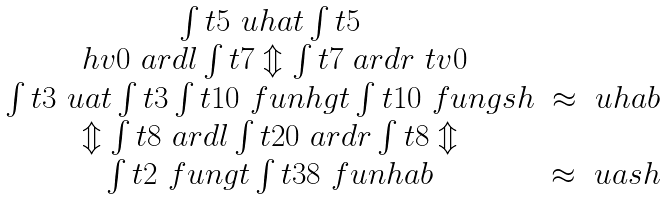<formula> <loc_0><loc_0><loc_500><loc_500>\begin{array} { c c } \int t { 5 } \ u h a t \int t { 5 } & \\ \ h v 0 \ a r d l \int t { 7 } \Updownarrow \int t { 7 } \ a r d r \ t v 0 & \\ \int t { 3 } \ u a t \int t { 3 } \int t { 1 0 } \ f u n h g t \int t { 1 0 } \ f u n g s h & \approx \ u h a b \\ \Updownarrow \int t { 8 } \ a r d l \int t { 2 0 } \ a r d r \int t { 8 } \Updownarrow & \\ \int t { 2 } \ f u n g t \int t { 3 8 } \ f u n h a b & \approx \ u a s h \end{array}</formula> 